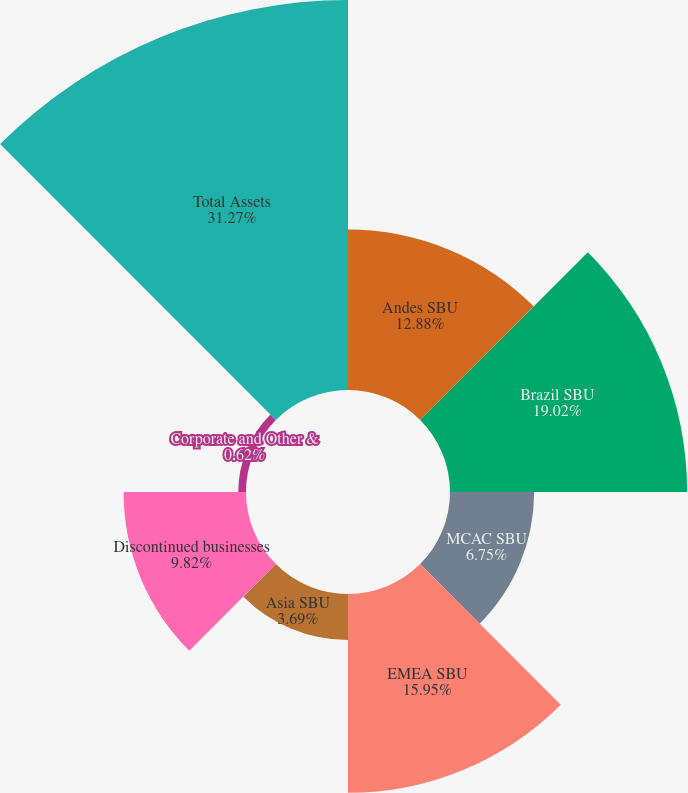<chart> <loc_0><loc_0><loc_500><loc_500><pie_chart><fcel>Andes SBU<fcel>Brazil SBU<fcel>MCAC SBU<fcel>EMEA SBU<fcel>Asia SBU<fcel>Discontinued businesses<fcel>Corporate and Other &<fcel>Total Assets<nl><fcel>12.88%<fcel>19.02%<fcel>6.75%<fcel>15.95%<fcel>3.69%<fcel>9.82%<fcel>0.62%<fcel>31.28%<nl></chart> 